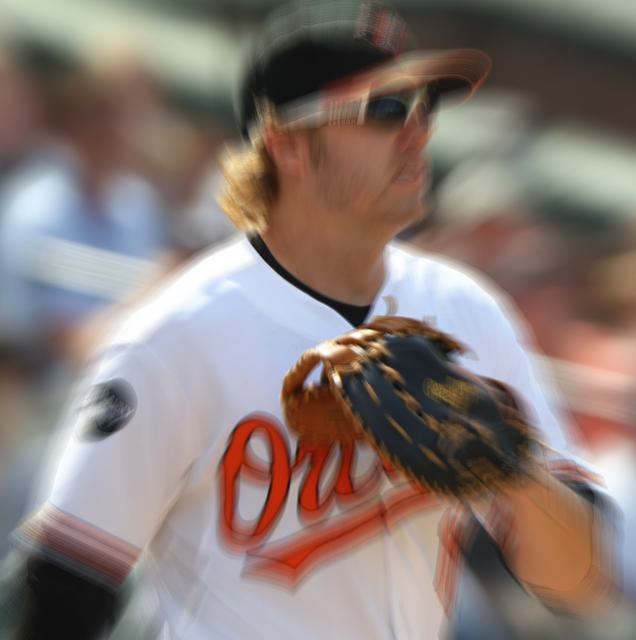What is the overall clarity of the image? The image has significant motion blur, causing a loss of sharpness and detail, particularly noticeable on the subject's face and hands. This effect may have been intentional to convey motion or could be due to a camera setting or movement during capture. The colors and contrast remain vivid, providing some visual interest despite the clarity issues. 